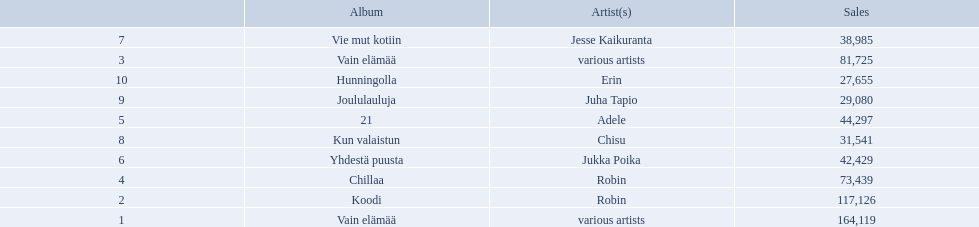Who is the artist for 21 album? Adele. Who is the artist for kun valaistun? Chisu. Which album had the same artist as chillaa? Koodi. 